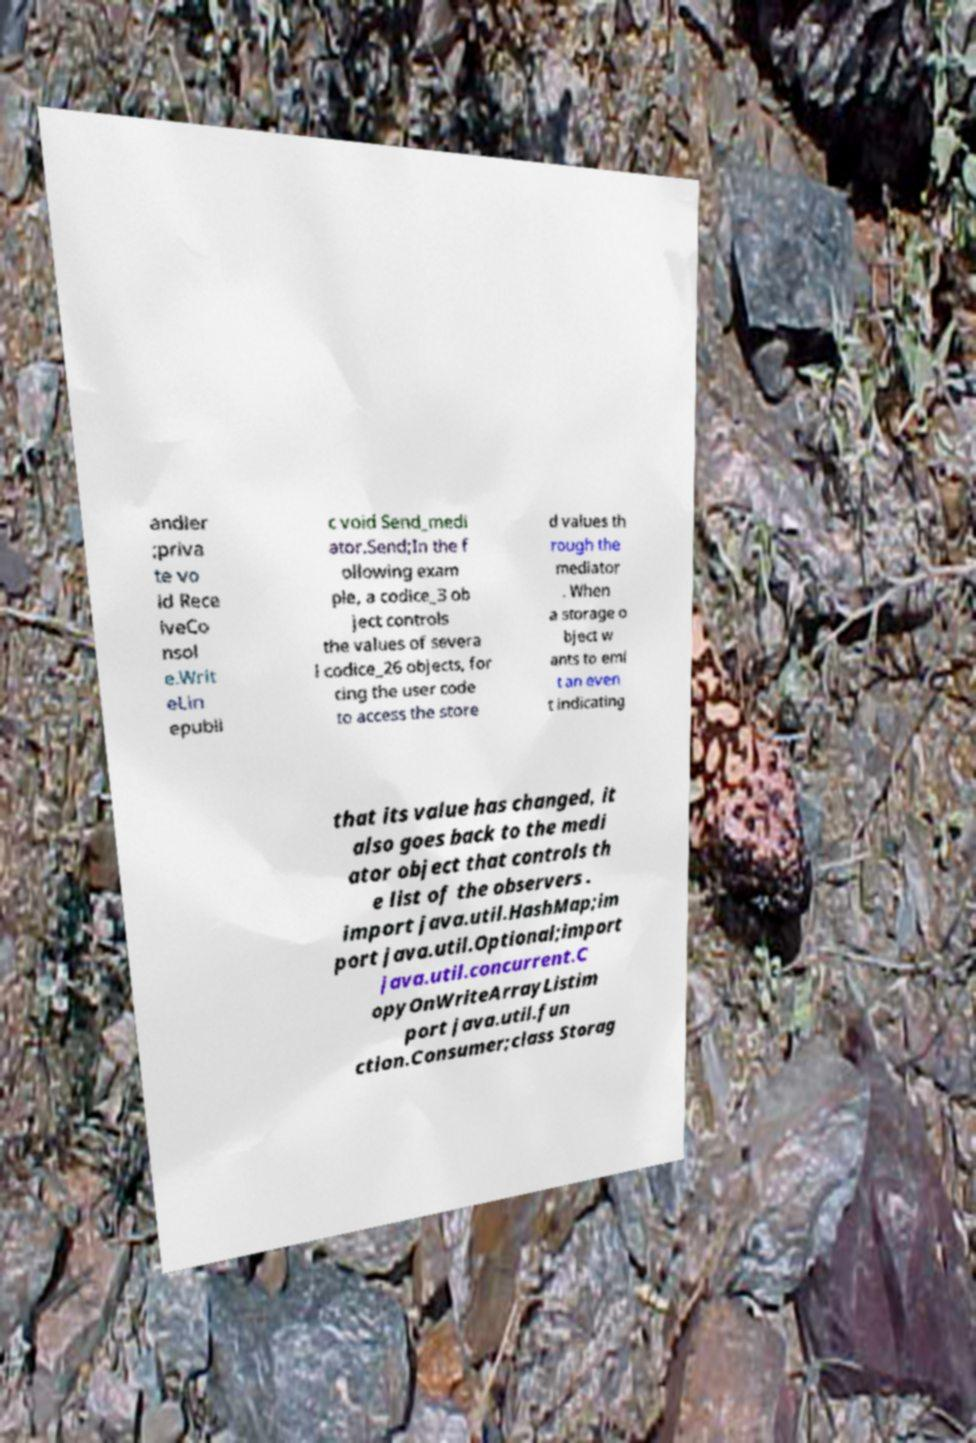For documentation purposes, I need the text within this image transcribed. Could you provide that? andler ;priva te vo id Rece iveCo nsol e.Writ eLin epubli c void Send_medi ator.Send;In the f ollowing exam ple, a codice_3 ob ject controls the values of severa l codice_26 objects, for cing the user code to access the store d values th rough the mediator . When a storage o bject w ants to emi t an even t indicating that its value has changed, it also goes back to the medi ator object that controls th e list of the observers . import java.util.HashMap;im port java.util.Optional;import java.util.concurrent.C opyOnWriteArrayListim port java.util.fun ction.Consumer;class Storag 